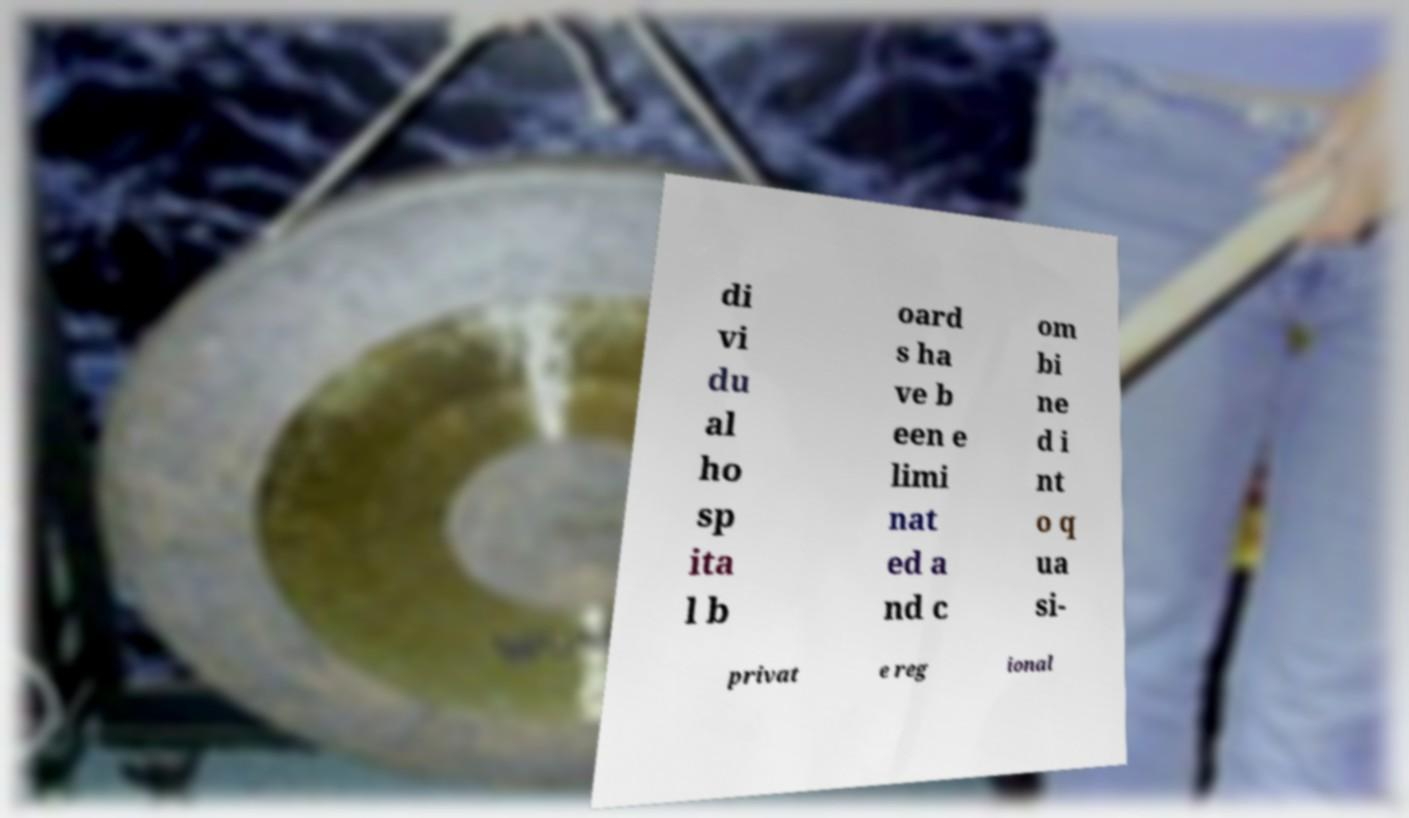There's text embedded in this image that I need extracted. Can you transcribe it verbatim? di vi du al ho sp ita l b oard s ha ve b een e limi nat ed a nd c om bi ne d i nt o q ua si- privat e reg ional 